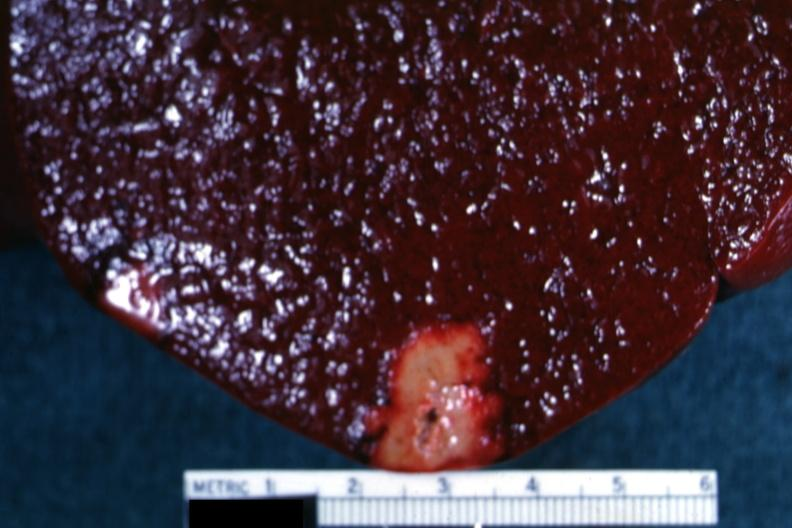s hematologic present?
Answer the question using a single word or phrase. Yes 